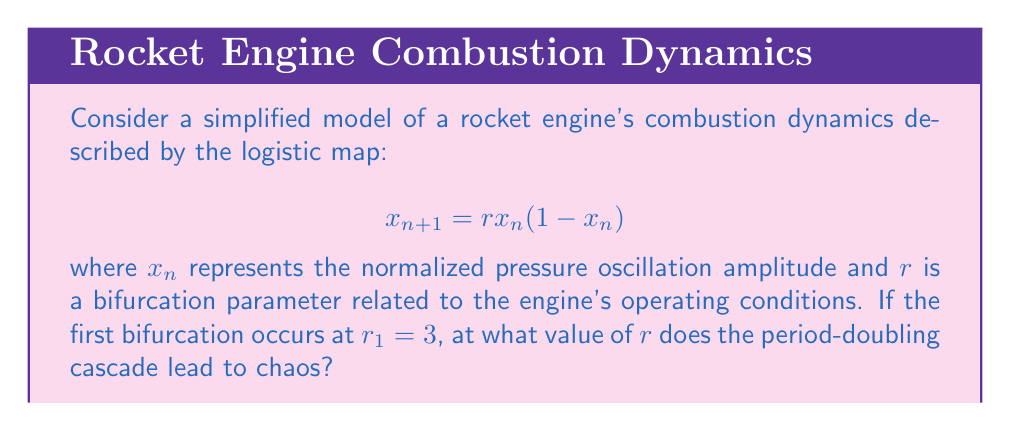Can you answer this question? To solve this problem, we need to understand the period-doubling route to chaos in the logistic map:

1) The logistic map undergoes a series of period-doubling bifurcations as $r$ increases.

2) The first bifurcation occurs at $r_1 = 3$, as given in the question.

3) Subsequent bifurcations occur at decreasing intervals, following a geometric sequence.

4) The ratio between successive bifurcation intervals converges to the Feigenbaum constant:

   $$\delta = \lim_{n \to \infty} \frac{r_n - r_{n-1}}{r_{n+1} - r_n} \approx 4.669201609...$$

5) The accumulation point of this sequence, $r_\infty$, marks the onset of chaos.

6) We can approximate $r_\infty$ using the formula:

   $$r_\infty \approx r_n + \frac{r_n - r_{n-1}}{\delta - 1}$$

7) For the logistic map, we know $r_1 = 3$ and $r_2 \approx 3.449490...$ 

8) Substituting these values:

   $$r_\infty \approx 3.449490 + \frac{3.449490 - 3}{4.669201609 - 1} \approx 3.569946...$$

Therefore, the period-doubling cascade leads to chaos at approximately $r = 3.569946$.
Answer: $r \approx 3.569946$ 